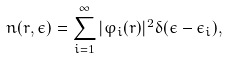<formula> <loc_0><loc_0><loc_500><loc_500>n ( { r } , \epsilon ) = \sum _ { i = 1 } ^ { \infty } | \varphi _ { i } ( { r } ) | ^ { 2 } \delta ( \epsilon - \epsilon _ { i } ) ,</formula> 